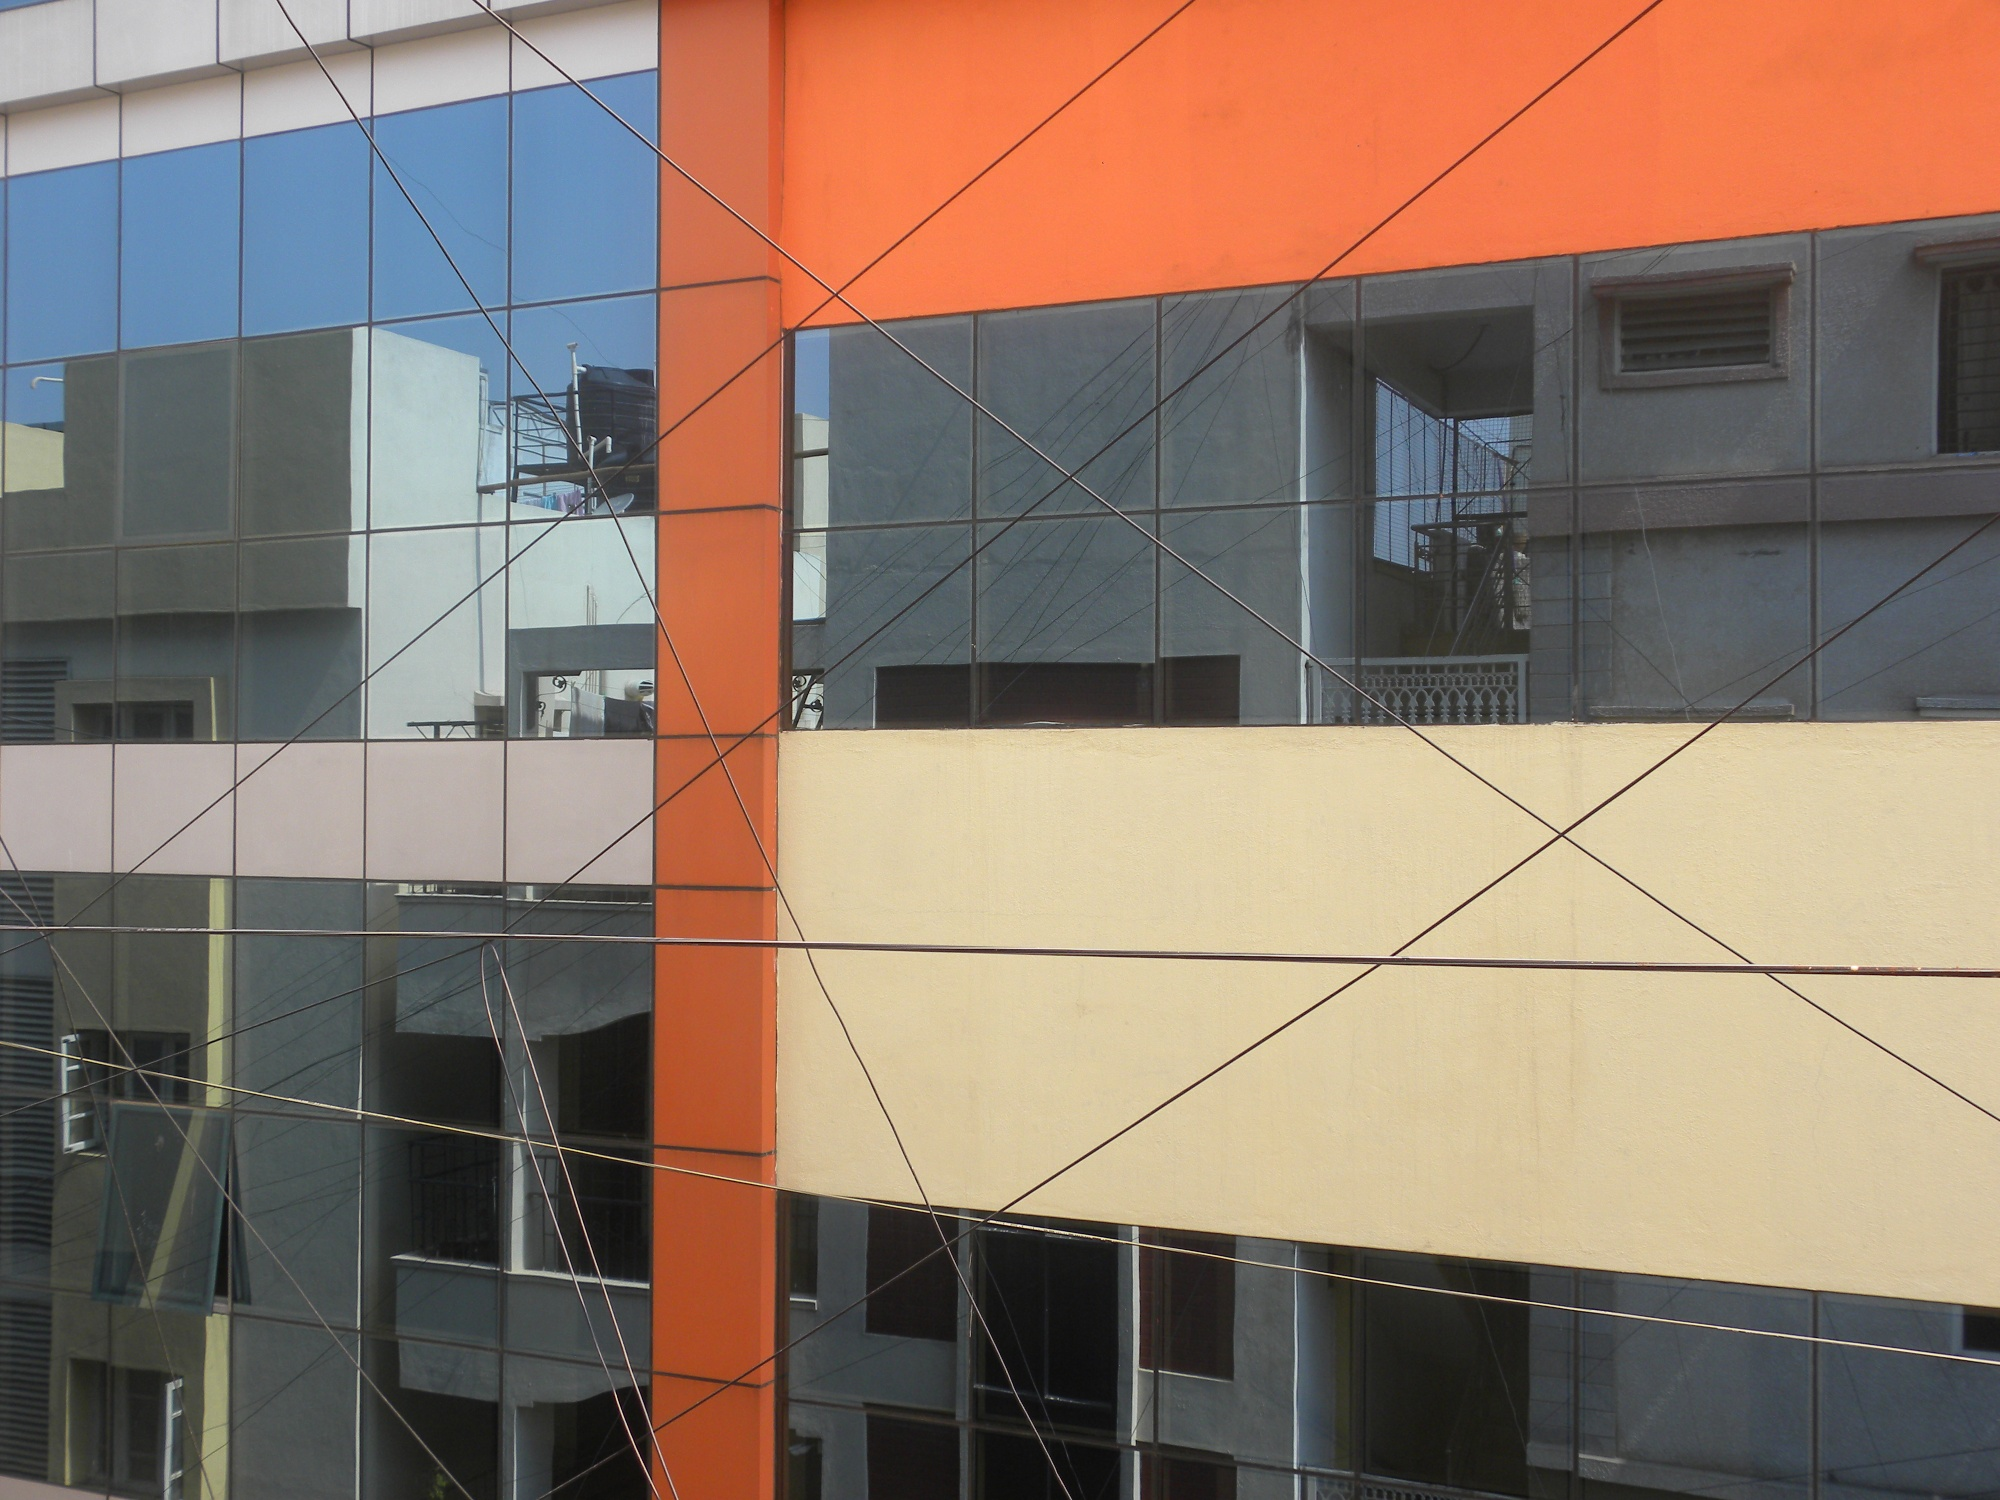Imagine if this building could talk. What stories might it tell? If the building could talk, it might share tales of the bustling urban life that surrounds it. It could reveal the dynamic interactions of the people passing by every day, the changes in the neighborhood skyline over the years, and the countless moments captured in its reflective glass windows. It might narrate stories of the architects who designed it, the trials and triumphs of its construction, and the pride it feels standing tall amidst the city’s ever-evolving landscape. Do you think the wires in front of the building affect its overall look? Yes, the wires crisscrossing in front of the building do impact its overall look. They introduce an additional layer of complexity and abstraction, creating a contrast with the clean and modern lines of the facade. While they partially obstruct the view, they also add a unique, industrial element that may appeal to some viewers as a blend of urban aesthetics with modern architecture.  Can you write a short story set in this building? In the heart of the city, this three-story building stood as a silent witness to countless stories. On the top floor, a young artist named Clara had transformed her apartment into a studio. Each morning, she would step onto her balcony with a cup of coffee, drawing inspiration from the reflections in the building’s glass windows. One day, she noticed a mysterious figure appearing in the reflections, always standing at the sharegpt4v/same spot, and looking towards her. Intrigued, Clara decided to investigate. After a series of unexpected events, she discovered the figure was a fellow artist from the adjacent building, trying to catch a glimpse of her work. This marked the beginning of their unexpected collaboration, leading to a beautiful fusion of their unique styles and an everlasting friendship. 